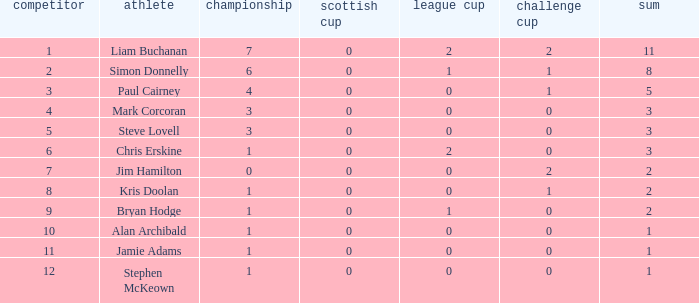What is Kris doolan's league number? 1.0. 